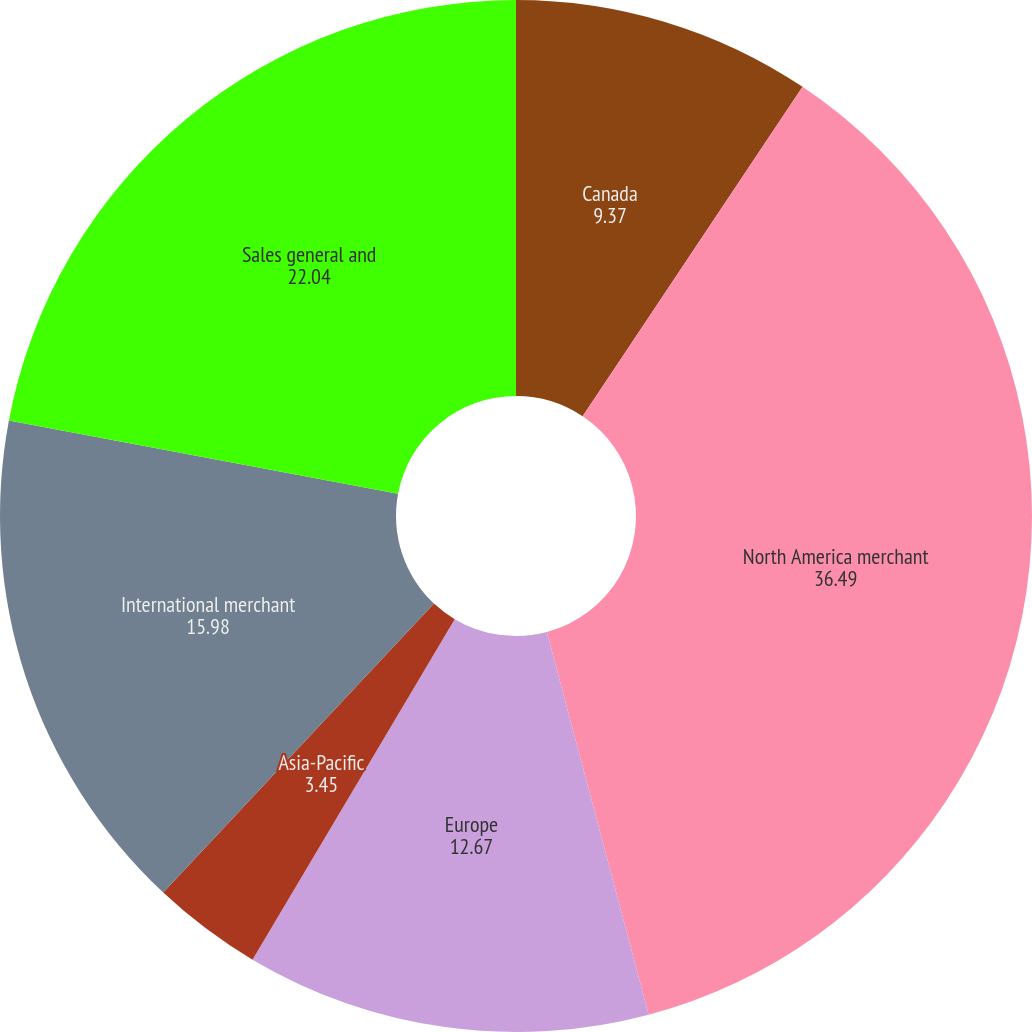Convert chart. <chart><loc_0><loc_0><loc_500><loc_500><pie_chart><fcel>Canada<fcel>North America merchant<fcel>Europe<fcel>Asia-Pacific<fcel>International merchant<fcel>Sales general and<nl><fcel>9.37%<fcel>36.49%<fcel>12.67%<fcel>3.45%<fcel>15.98%<fcel>22.04%<nl></chart> 